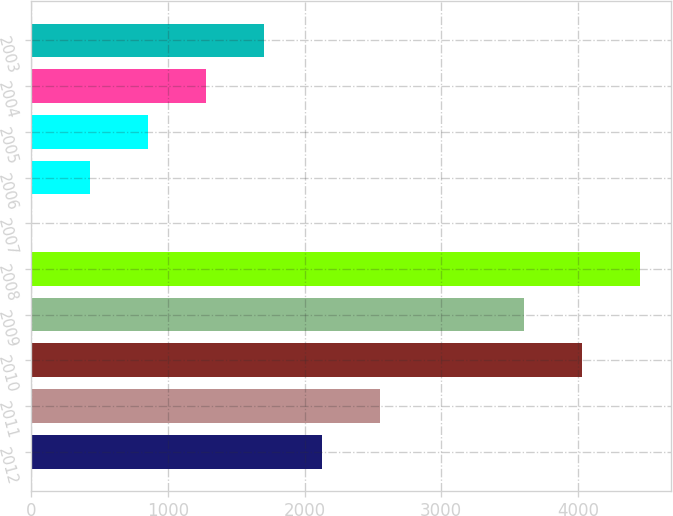Convert chart. <chart><loc_0><loc_0><loc_500><loc_500><bar_chart><fcel>2012<fcel>2011<fcel>2010<fcel>2009<fcel>2008<fcel>2007<fcel>2006<fcel>2005<fcel>2004<fcel>2003<nl><fcel>2125<fcel>2548.2<fcel>4032.2<fcel>3609<fcel>4455.4<fcel>9<fcel>432.2<fcel>855.4<fcel>1278.6<fcel>1701.8<nl></chart> 